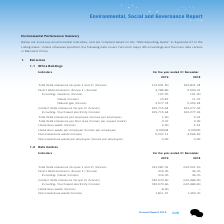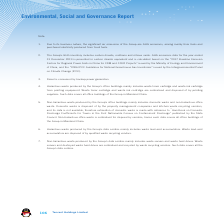According to Tencent's financial document, What is diesel consumed by? backup power generators. The document states: "3. Diesel is consumed by backup power generators...." Also, What does the hazardous waste produced by the Group's data centres mainly include? waste lead-acid accumulators. The document states: "duced by the Group’s data centres mainly includes waste lead-acid accumulators. Waste lead-acid duced by the Group’s data centres mainly includes wast..." Also, What does the non-hazardous waste produced by the Group's data centres mainly include? waste servers and waste hard drives. The document states: "duced by the Group’s data centres mainly includes waste servers and waste hard drives. Waste..." Also, can you calculate: What is the difference between 2018 and 2019 Total GHG emissions in tonnes? Based on the calculation: 113,501.50-102,831.74, the result is 10669.76. This is based on the information: "HG emissions (Scopes 1 and 2) (tonnes) 113,501.50 102,831.74 Total GHG emissions (Scopes 1 and 2) (tonnes) 113,501.50 102,831.74..." The key data points involved are: 102,831.74, 113,501.50. Also, can you calculate: What is the difference between 2018 and 2019 indirect GHG emissions in tonnes? Based on the calculation: 109,715.64-100,277.43, the result is 9438.21. This is based on the information: "irect GHG emissions (Scope 2) (tonnes) 109,715.64 100,277.43 Indirect GHG emissions (Scope 2) (tonnes) 109,715.64 100,277.43..." The key data points involved are: 100,277.43, 109,715.64. Also, can you calculate: What is the change between 2018 and 2019 hazardous waste(tonnes)? Based on the calculation: 2.40-2.51, the result is -0.11. This is based on the information: "Hazardous waste (tonnes) 2.40 2.51 Hazardous waste (tonnes) 2.40 2.51..." The key data points involved are: 2.40, 2.51. 